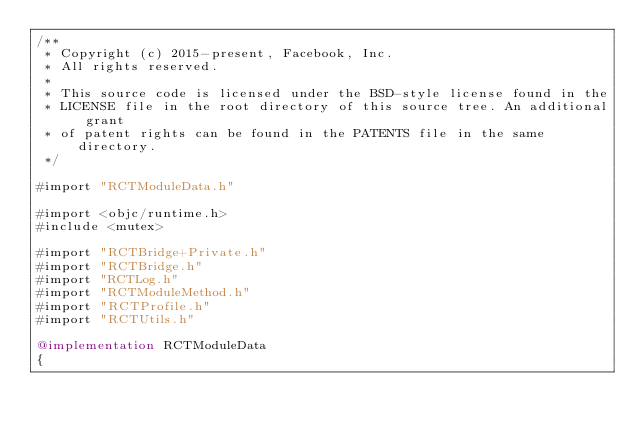Convert code to text. <code><loc_0><loc_0><loc_500><loc_500><_ObjectiveC_>/**
 * Copyright (c) 2015-present, Facebook, Inc.
 * All rights reserved.
 *
 * This source code is licensed under the BSD-style license found in the
 * LICENSE file in the root directory of this source tree. An additional grant
 * of patent rights can be found in the PATENTS file in the same directory.
 */

#import "RCTModuleData.h"

#import <objc/runtime.h>
#include <mutex>

#import "RCTBridge+Private.h"
#import "RCTBridge.h"
#import "RCTLog.h"
#import "RCTModuleMethod.h"
#import "RCTProfile.h"
#import "RCTUtils.h"

@implementation RCTModuleData
{</code> 